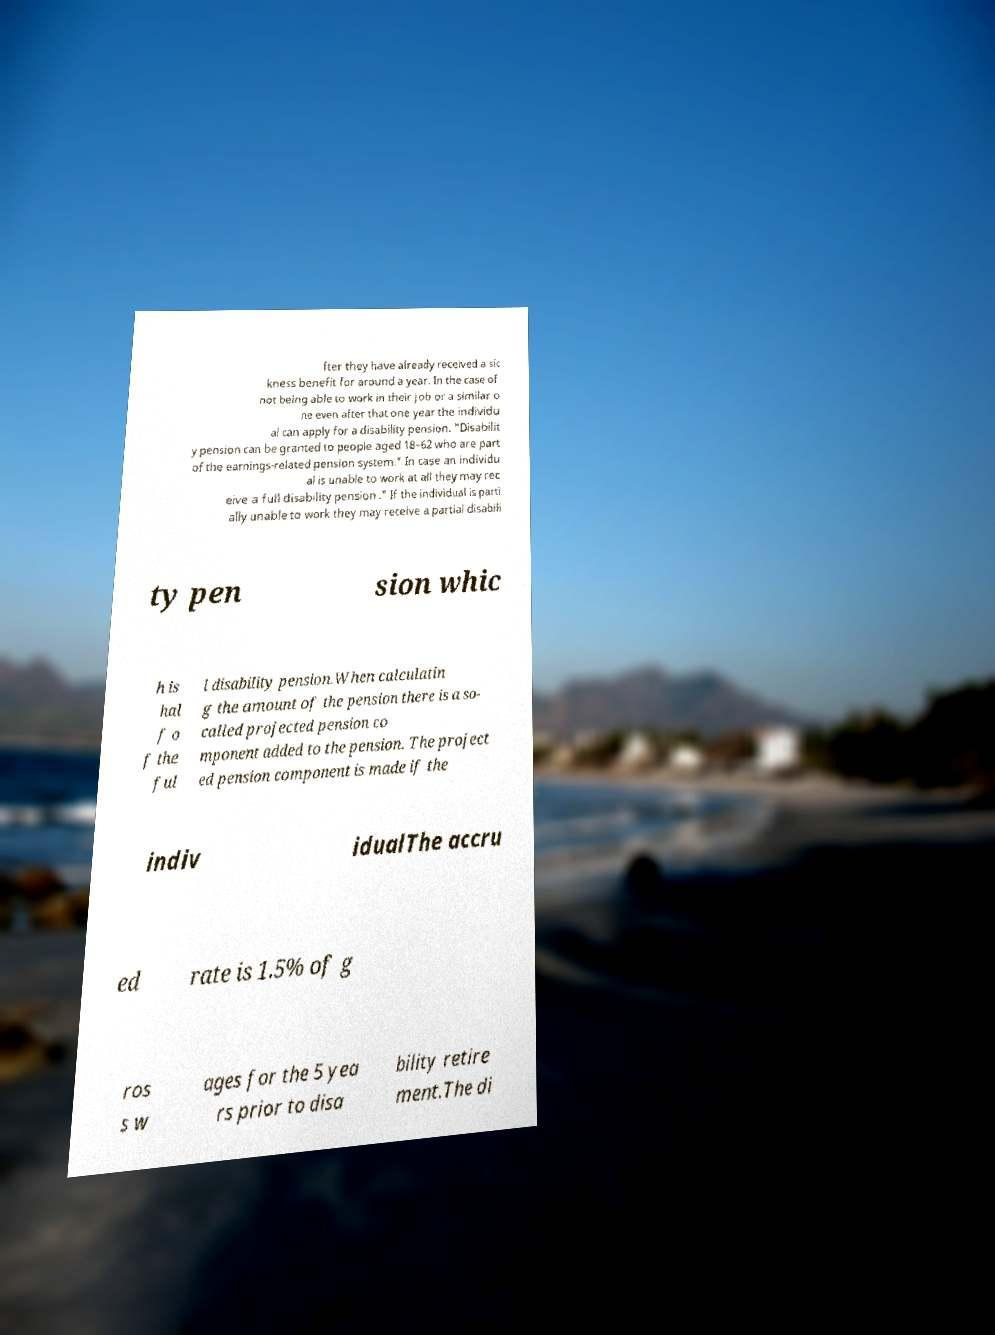For documentation purposes, I need the text within this image transcribed. Could you provide that? fter they have already received a sic kness benefit for around a year. In the case of not being able to work in their job or a similar o ne even after that one year the individu al can apply for a disability pension. "Disabilit y pension can be granted to people aged 18–62 who are part of the earnings-related pension system." In case an individu al is unable to work at all they may rec eive a full disability pension ." If the individual is parti ally unable to work they may receive a partial disabili ty pen sion whic h is hal f o f the ful l disability pension.When calculatin g the amount of the pension there is a so- called projected pension co mponent added to the pension. The project ed pension component is made if the indiv idualThe accru ed rate is 1.5% of g ros s w ages for the 5 yea rs prior to disa bility retire ment.The di 